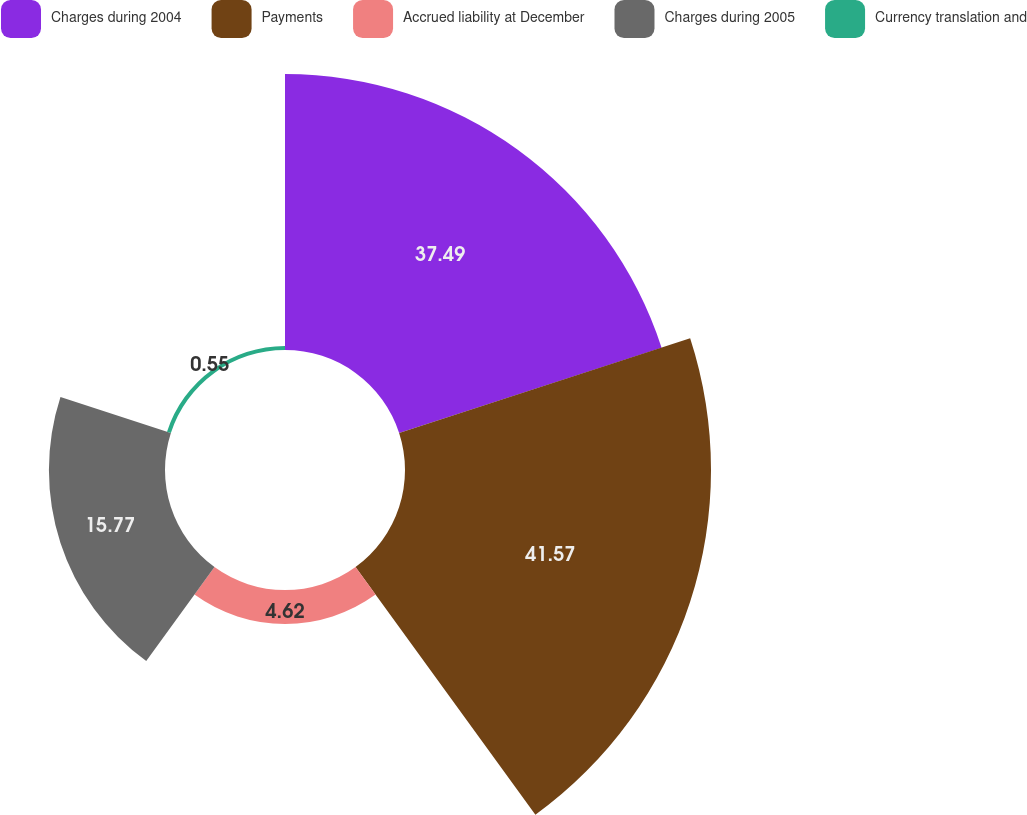Convert chart. <chart><loc_0><loc_0><loc_500><loc_500><pie_chart><fcel>Charges during 2004<fcel>Payments<fcel>Accrued liability at December<fcel>Charges during 2005<fcel>Currency translation and<nl><fcel>37.49%<fcel>41.57%<fcel>4.62%<fcel>15.77%<fcel>0.55%<nl></chart> 